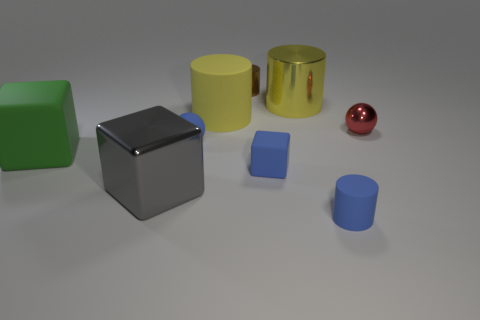Add 1 large gray metal things. How many objects exist? 10 Subtract all balls. How many objects are left? 7 Add 7 big matte blocks. How many big matte blocks are left? 8 Add 7 small blue rubber cubes. How many small blue rubber cubes exist? 8 Subtract 1 gray cubes. How many objects are left? 8 Subtract all tiny blue rubber cubes. Subtract all brown cylinders. How many objects are left? 7 